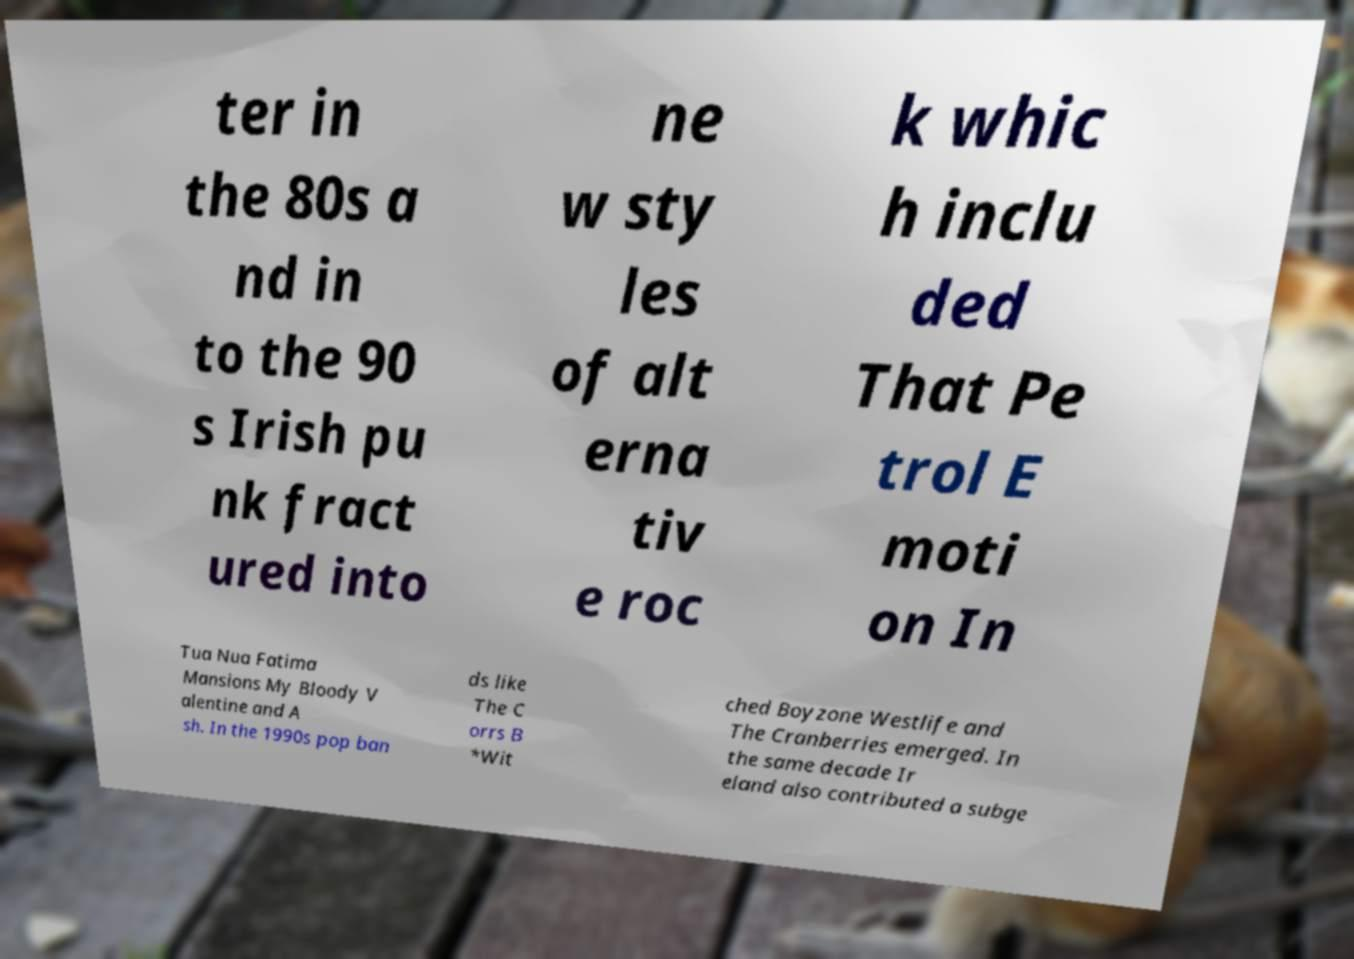Can you accurately transcribe the text from the provided image for me? ter in the 80s a nd in to the 90 s Irish pu nk fract ured into ne w sty les of alt erna tiv e roc k whic h inclu ded That Pe trol E moti on In Tua Nua Fatima Mansions My Bloody V alentine and A sh. In the 1990s pop ban ds like The C orrs B *Wit ched Boyzone Westlife and The Cranberries emerged. In the same decade Ir eland also contributed a subge 